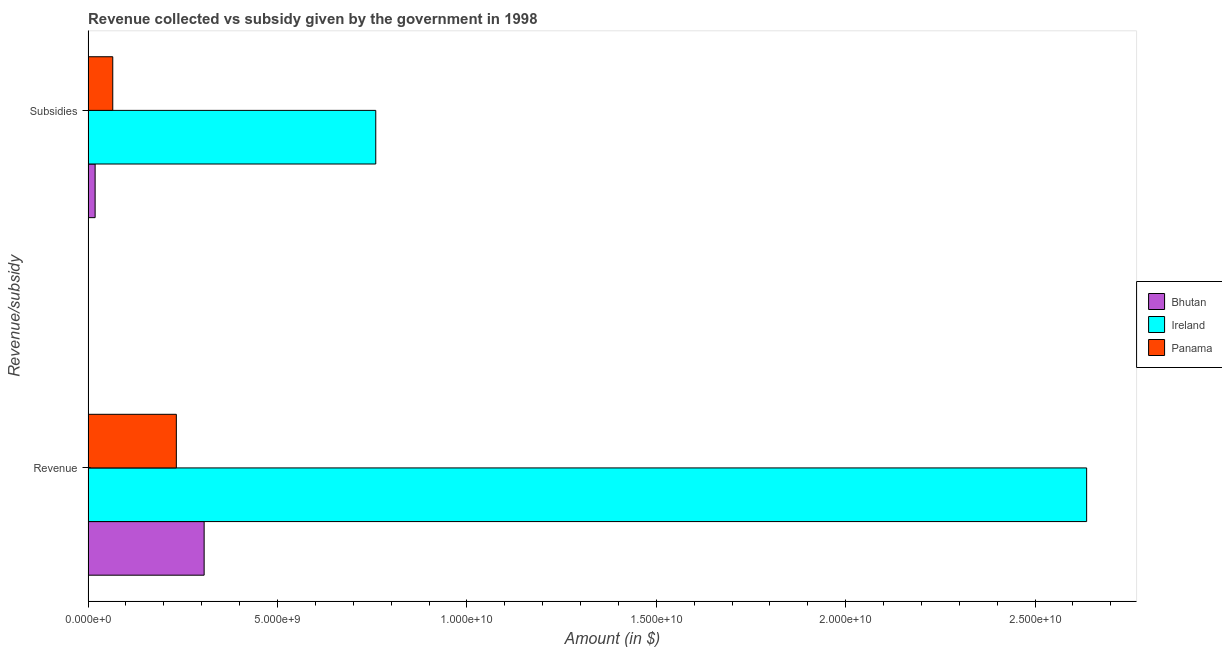How many groups of bars are there?
Provide a succinct answer. 2. How many bars are there on the 1st tick from the top?
Offer a very short reply. 3. What is the label of the 1st group of bars from the top?
Your answer should be very brief. Subsidies. What is the amount of revenue collected in Bhutan?
Keep it short and to the point. 3.06e+09. Across all countries, what is the maximum amount of revenue collected?
Offer a terse response. 2.64e+1. Across all countries, what is the minimum amount of revenue collected?
Provide a succinct answer. 2.33e+09. In which country was the amount of subsidies given maximum?
Your answer should be compact. Ireland. In which country was the amount of revenue collected minimum?
Provide a succinct answer. Panama. What is the total amount of revenue collected in the graph?
Offer a terse response. 3.18e+1. What is the difference between the amount of subsidies given in Ireland and that in Bhutan?
Your answer should be compact. 7.41e+09. What is the difference between the amount of subsidies given in Ireland and the amount of revenue collected in Bhutan?
Your response must be concise. 4.53e+09. What is the average amount of subsidies given per country?
Offer a terse response. 2.81e+09. What is the difference between the amount of revenue collected and amount of subsidies given in Ireland?
Offer a terse response. 1.88e+1. What is the ratio of the amount of subsidies given in Ireland to that in Bhutan?
Your answer should be compact. 40.87. What does the 3rd bar from the top in Revenue represents?
Provide a succinct answer. Bhutan. What does the 1st bar from the bottom in Subsidies represents?
Give a very brief answer. Bhutan. How many bars are there?
Offer a terse response. 6. How many countries are there in the graph?
Ensure brevity in your answer.  3. What is the difference between two consecutive major ticks on the X-axis?
Keep it short and to the point. 5.00e+09. Does the graph contain any zero values?
Ensure brevity in your answer.  No. Where does the legend appear in the graph?
Give a very brief answer. Center right. How many legend labels are there?
Provide a short and direct response. 3. How are the legend labels stacked?
Provide a succinct answer. Vertical. What is the title of the graph?
Keep it short and to the point. Revenue collected vs subsidy given by the government in 1998. What is the label or title of the X-axis?
Keep it short and to the point. Amount (in $). What is the label or title of the Y-axis?
Provide a succinct answer. Revenue/subsidy. What is the Amount (in $) in Bhutan in Revenue?
Your answer should be compact. 3.06e+09. What is the Amount (in $) of Ireland in Revenue?
Your answer should be very brief. 2.64e+1. What is the Amount (in $) in Panama in Revenue?
Your answer should be very brief. 2.33e+09. What is the Amount (in $) of Bhutan in Subsidies?
Ensure brevity in your answer.  1.86e+08. What is the Amount (in $) in Ireland in Subsidies?
Make the answer very short. 7.59e+09. What is the Amount (in $) in Panama in Subsidies?
Provide a succinct answer. 6.52e+08. Across all Revenue/subsidy, what is the maximum Amount (in $) of Bhutan?
Your response must be concise. 3.06e+09. Across all Revenue/subsidy, what is the maximum Amount (in $) in Ireland?
Your response must be concise. 2.64e+1. Across all Revenue/subsidy, what is the maximum Amount (in $) of Panama?
Make the answer very short. 2.33e+09. Across all Revenue/subsidy, what is the minimum Amount (in $) in Bhutan?
Make the answer very short. 1.86e+08. Across all Revenue/subsidy, what is the minimum Amount (in $) in Ireland?
Offer a terse response. 7.59e+09. Across all Revenue/subsidy, what is the minimum Amount (in $) in Panama?
Give a very brief answer. 6.52e+08. What is the total Amount (in $) of Bhutan in the graph?
Ensure brevity in your answer.  3.25e+09. What is the total Amount (in $) of Ireland in the graph?
Offer a terse response. 3.40e+1. What is the total Amount (in $) of Panama in the graph?
Provide a succinct answer. 2.98e+09. What is the difference between the Amount (in $) of Bhutan in Revenue and that in Subsidies?
Your response must be concise. 2.88e+09. What is the difference between the Amount (in $) in Ireland in Revenue and that in Subsidies?
Make the answer very short. 1.88e+1. What is the difference between the Amount (in $) in Panama in Revenue and that in Subsidies?
Provide a short and direct response. 1.68e+09. What is the difference between the Amount (in $) in Bhutan in Revenue and the Amount (in $) in Ireland in Subsidies?
Provide a succinct answer. -4.53e+09. What is the difference between the Amount (in $) of Bhutan in Revenue and the Amount (in $) of Panama in Subsidies?
Provide a succinct answer. 2.41e+09. What is the difference between the Amount (in $) of Ireland in Revenue and the Amount (in $) of Panama in Subsidies?
Make the answer very short. 2.57e+1. What is the average Amount (in $) in Bhutan per Revenue/subsidy?
Your answer should be very brief. 1.62e+09. What is the average Amount (in $) of Ireland per Revenue/subsidy?
Your answer should be very brief. 1.70e+1. What is the average Amount (in $) of Panama per Revenue/subsidy?
Give a very brief answer. 1.49e+09. What is the difference between the Amount (in $) of Bhutan and Amount (in $) of Ireland in Revenue?
Make the answer very short. -2.33e+1. What is the difference between the Amount (in $) of Bhutan and Amount (in $) of Panama in Revenue?
Provide a short and direct response. 7.34e+08. What is the difference between the Amount (in $) in Ireland and Amount (in $) in Panama in Revenue?
Keep it short and to the point. 2.40e+1. What is the difference between the Amount (in $) in Bhutan and Amount (in $) in Ireland in Subsidies?
Your response must be concise. -7.41e+09. What is the difference between the Amount (in $) in Bhutan and Amount (in $) in Panama in Subsidies?
Ensure brevity in your answer.  -4.66e+08. What is the difference between the Amount (in $) of Ireland and Amount (in $) of Panama in Subsidies?
Your answer should be very brief. 6.94e+09. What is the ratio of the Amount (in $) of Bhutan in Revenue to that in Subsidies?
Make the answer very short. 16.49. What is the ratio of the Amount (in $) of Ireland in Revenue to that in Subsidies?
Offer a terse response. 3.47. What is the ratio of the Amount (in $) of Panama in Revenue to that in Subsidies?
Provide a short and direct response. 3.58. What is the difference between the highest and the second highest Amount (in $) of Bhutan?
Offer a terse response. 2.88e+09. What is the difference between the highest and the second highest Amount (in $) in Ireland?
Make the answer very short. 1.88e+1. What is the difference between the highest and the second highest Amount (in $) of Panama?
Ensure brevity in your answer.  1.68e+09. What is the difference between the highest and the lowest Amount (in $) of Bhutan?
Keep it short and to the point. 2.88e+09. What is the difference between the highest and the lowest Amount (in $) in Ireland?
Provide a short and direct response. 1.88e+1. What is the difference between the highest and the lowest Amount (in $) in Panama?
Provide a succinct answer. 1.68e+09. 